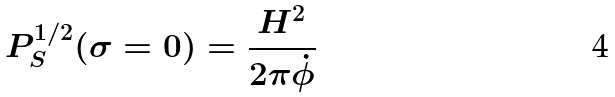<formula> <loc_0><loc_0><loc_500><loc_500>P _ { S } ^ { 1 / 2 } ( \sigma = 0 ) = \frac { H ^ { 2 } } { 2 \pi \dot { \phi } }</formula> 